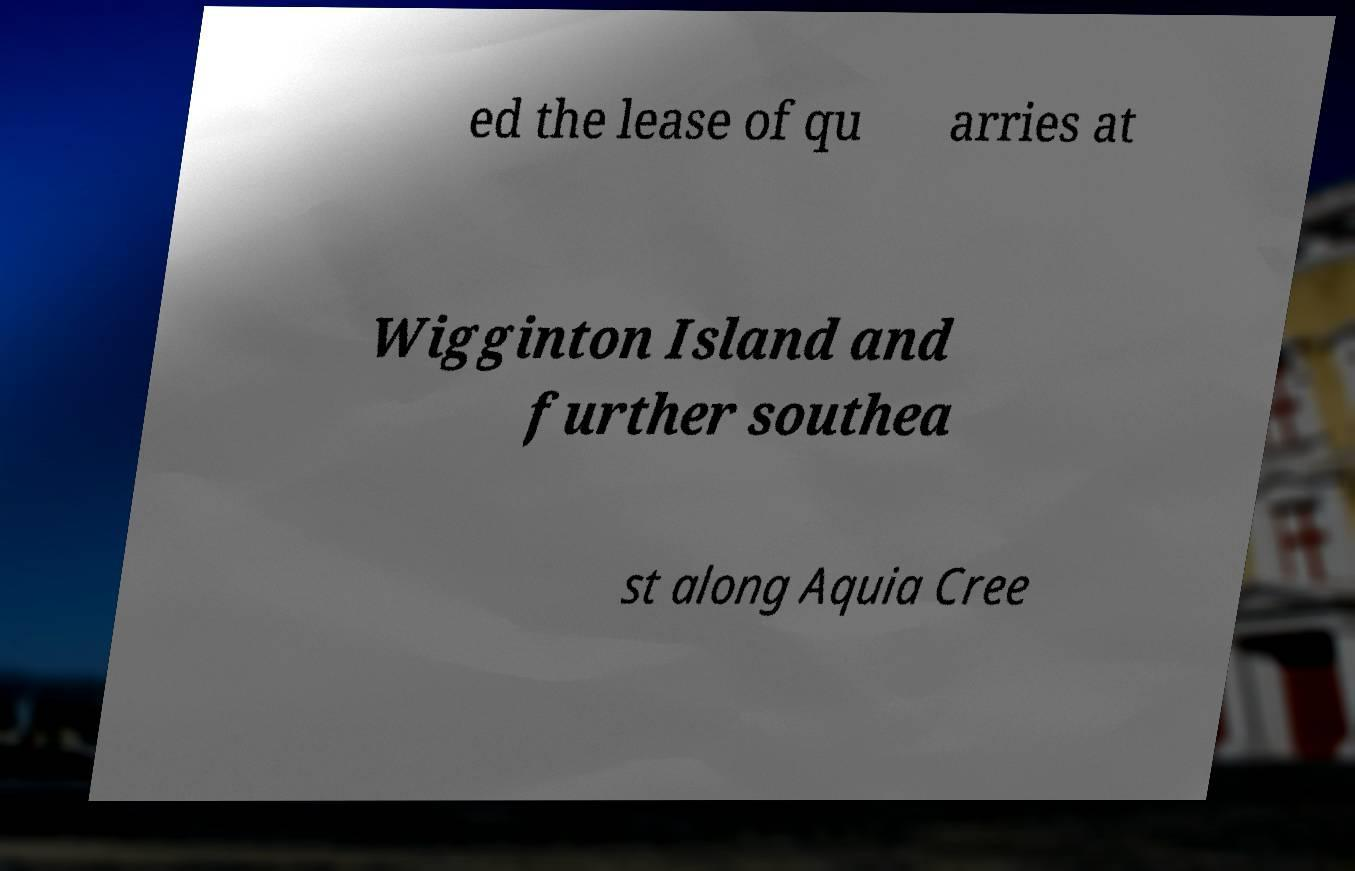Please read and relay the text visible in this image. What does it say? ed the lease of qu arries at Wigginton Island and further southea st along Aquia Cree 